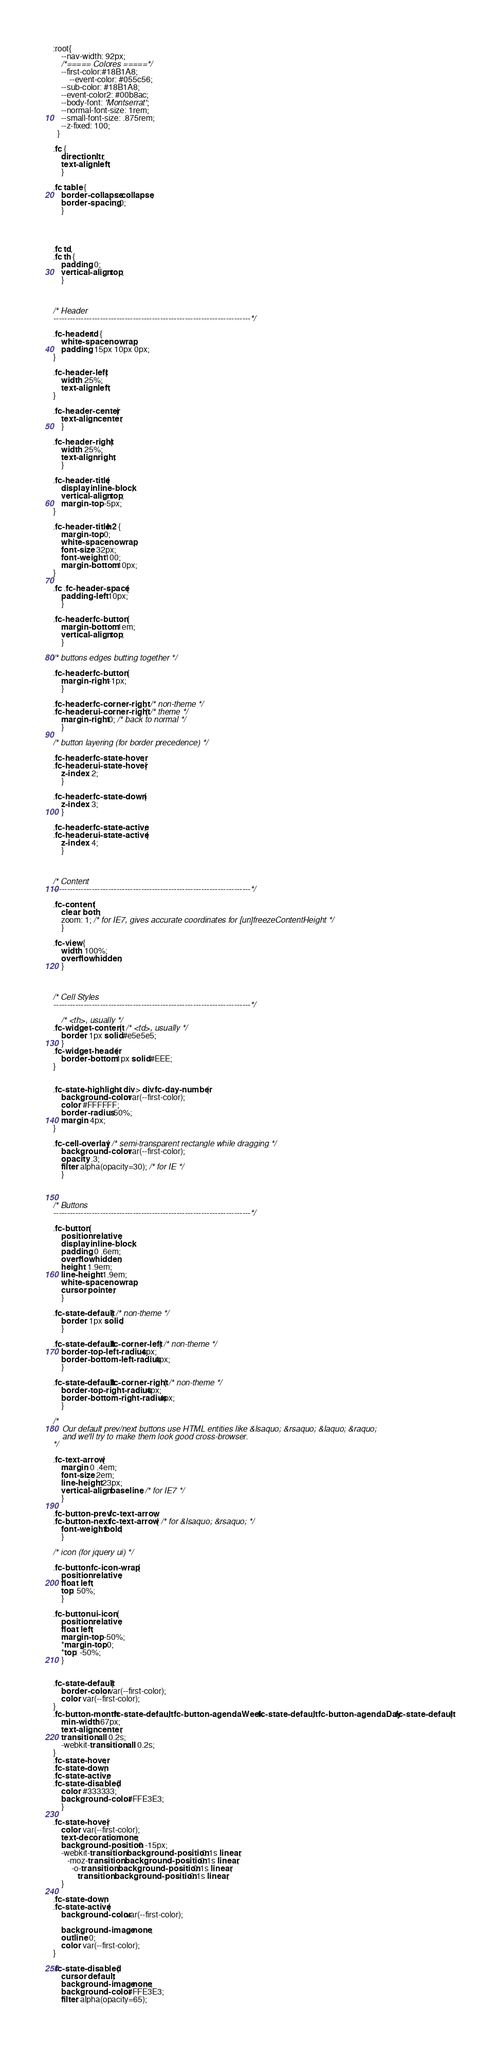Convert code to text. <code><loc_0><loc_0><loc_500><loc_500><_CSS_>:root{
	--nav-width: 92px; 
	/*===== Colores =====*/
	--first-color:#18B1A8;
		--event-color: #055c56;
	--sub-color: #18B1A8;
	--event-color2: #00b8ac;
	--body-font: 'Montserrat';
	--normal-font-size: 1rem;
	--small-font-size: .875rem;
	--z-fixed: 100;
  }

.fc {
	direction: ltr;
	text-align: left;
	}
	
.fc table {
	border-collapse: collapse;
	border-spacing: 0;
	}
	

	
	
.fc td,
.fc th {
	padding: 0;
	vertical-align: top;
	}



/* Header
------------------------------------------------------------------------*/

.fc-header td {
	white-space: nowrap;
	padding: 15px 10px 0px;
}

.fc-header-left {
	width: 25%;
	text-align: left;
}
	
.fc-header-center {
	text-align: center;
	}
	
.fc-header-right {
	width: 25%;
	text-align: right;
	}
	
.fc-header-title {
	display: inline-block;
	vertical-align: top;
	margin-top: -5px;
}
	
.fc-header-title h2 {
	margin-top: 0;
	white-space: nowrap;
	font-size: 32px;
    font-weight: 100;
    margin-bottom: 10px;
}
	
.fc .fc-header-space {
	padding-left: 10px;
	}
	
.fc-header .fc-button {
	margin-bottom: 1em;
	vertical-align: top;
	}
	
/* buttons edges butting together */

.fc-header .fc-button {
	margin-right: -1px;
	}
	
.fc-header .fc-corner-right,  /* non-theme */
.fc-header .ui-corner-right { /* theme */
	margin-right: 0; /* back to normal */
	}
	
/* button layering (for border precedence) */
	
.fc-header .fc-state-hover,
.fc-header .ui-state-hover {
	z-index: 2;
	}
	
.fc-header .fc-state-down {
	z-index: 3;
	}

.fc-header .fc-state-active,
.fc-header .ui-state-active {
	z-index: 4;
	}
	
	
	
/* Content
------------------------------------------------------------------------*/
	
.fc-content {
	clear: both;
	zoom: 1; /* for IE7, gives accurate coordinates for [un]freezeContentHeight */
	}
	
.fc-view {
	width: 100%;
	overflow: hidden;
	}
	
	

/* Cell Styles
------------------------------------------------------------------------*/

    /* <th>, usually */
.fc-widget-content {  /* <td>, usually */
	border: 1px solid #e5e5e5;
	}
.fc-widget-header{
    border-bottom: 1px solid #EEE; 
}	


.fc-state-highlight > div > div.fc-day-number{
    background-color: var(--first-color);
    color: #FFFFFF;
    border-radius: 50%;
    margin: 4px;
}
	
.fc-cell-overlay { /* semi-transparent rectangle while dragging */
	background-color: var(--first-color);
	opacity: .3;
	filter: alpha(opacity=30); /* for IE */
	}
	


/* Buttons
------------------------------------------------------------------------*/

.fc-button {
	position: relative;
	display: inline-block;
	padding: 0 .6em;
	overflow: hidden;
	height: 1.9em;
	line-height: 1.9em;
	white-space: nowrap;
	cursor: pointer;
	}
	
.fc-state-default { /* non-theme */
	border: 1px solid;
	}

.fc-state-default.fc-corner-left { /* non-theme */
	border-top-left-radius: 4px;
	border-bottom-left-radius: 4px;
	}

.fc-state-default.fc-corner-right { /* non-theme */
	border-top-right-radius: 4px;
	border-bottom-right-radius: 4px;
	}

/*
	Our default prev/next buttons use HTML entities like &lsaquo; &rsaquo; &laquo; &raquo;
	and we'll try to make them look good cross-browser.
*/

.fc-text-arrow {
	margin: 0 .4em;
	font-size: 2em;
	line-height: 23px;
	vertical-align: baseline; /* for IE7 */
	}

.fc-button-prev .fc-text-arrow,
.fc-button-next .fc-text-arrow { /* for &lsaquo; &rsaquo; */
	font-weight: bold;
	}
	
/* icon (for jquery ui) */
	
.fc-button .fc-icon-wrap {
	position: relative;
	float: left;
	top: 50%;
	}
	
.fc-button .ui-icon {
	position: relative;
	float: left;
	margin-top: -50%;
	*margin-top: 0;
	*top: -50%;
	}


.fc-state-default {
	border-color: var(--first-color);
	color: var(--first-color);
}
.fc-button-month.fc-state-default, .fc-button-agendaWeek.fc-state-default, .fc-button-agendaDay.fc-state-default{
    min-width: 67px;
	text-align: center;
	transition: all 0.2s;
	-webkit-transition: all 0.2s;
}
.fc-state-hover,
.fc-state-down,
.fc-state-active,
.fc-state-disabled {
	color: #333333;
	background-color: #FFE3E3;
	}

.fc-state-hover {
	color: var(--first-color);
	text-decoration: none;
	background-position: 0 -15px;
	-webkit-transition: background-position 0.1s linear;
	   -moz-transition: background-position 0.1s linear;
	     -o-transition: background-position 0.1s linear;
	        transition: background-position 0.1s linear;
	}

.fc-state-down,
.fc-state-active {
	background-color:var(--first-color);

	background-image: none;
	outline: 0;
	color: var(--first-color);
}

.fc-state-disabled {
	cursor: default;
	background-image: none;
	background-color: #FFE3E3;
	filter: alpha(opacity=65);</code> 